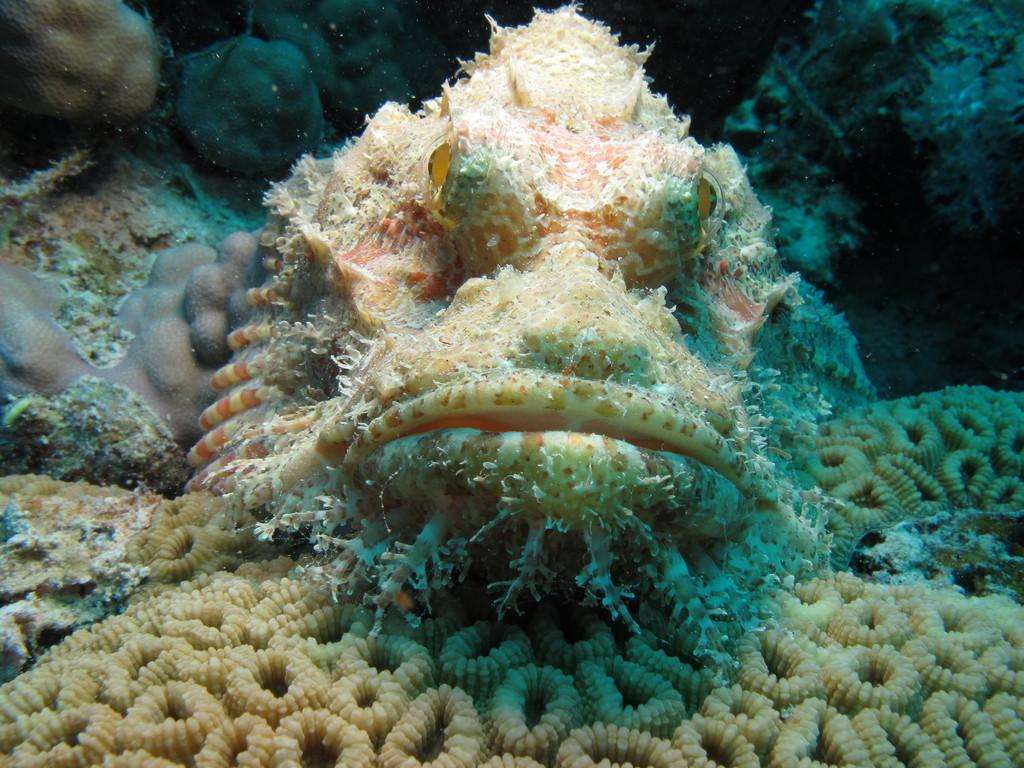What is the primary subject in the foreground of the image? There is a living thing in the water in the foreground of the image. What type of street can be seen in the image? There is no street present in the image; it features a living thing in the water in the foreground. How many stones are visible in the image? There is no mention of stones in the image; it only features a living thing in the water. 